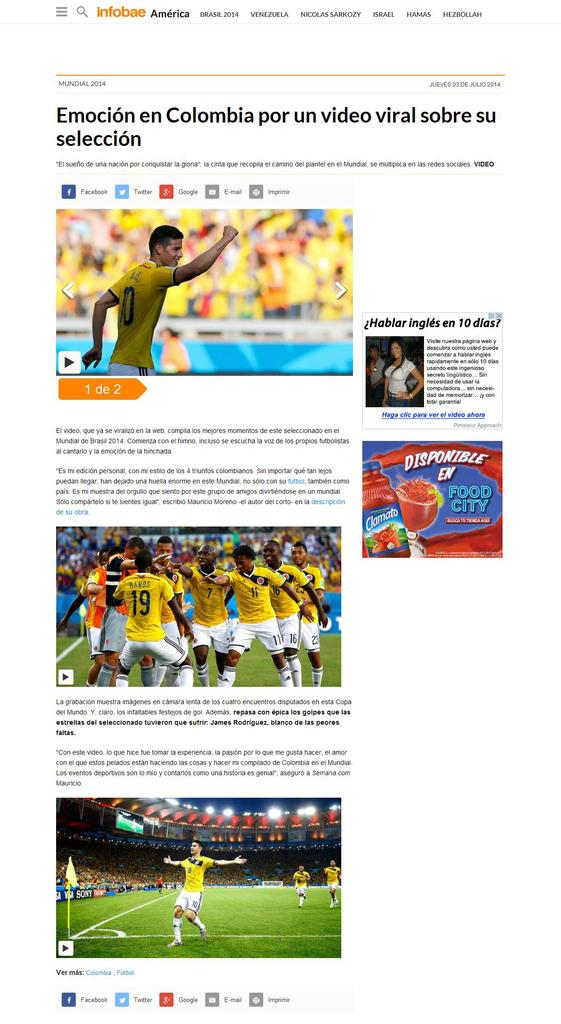<image>
Give a short and clear explanation of the subsequent image. The website being shown here is called infobae 